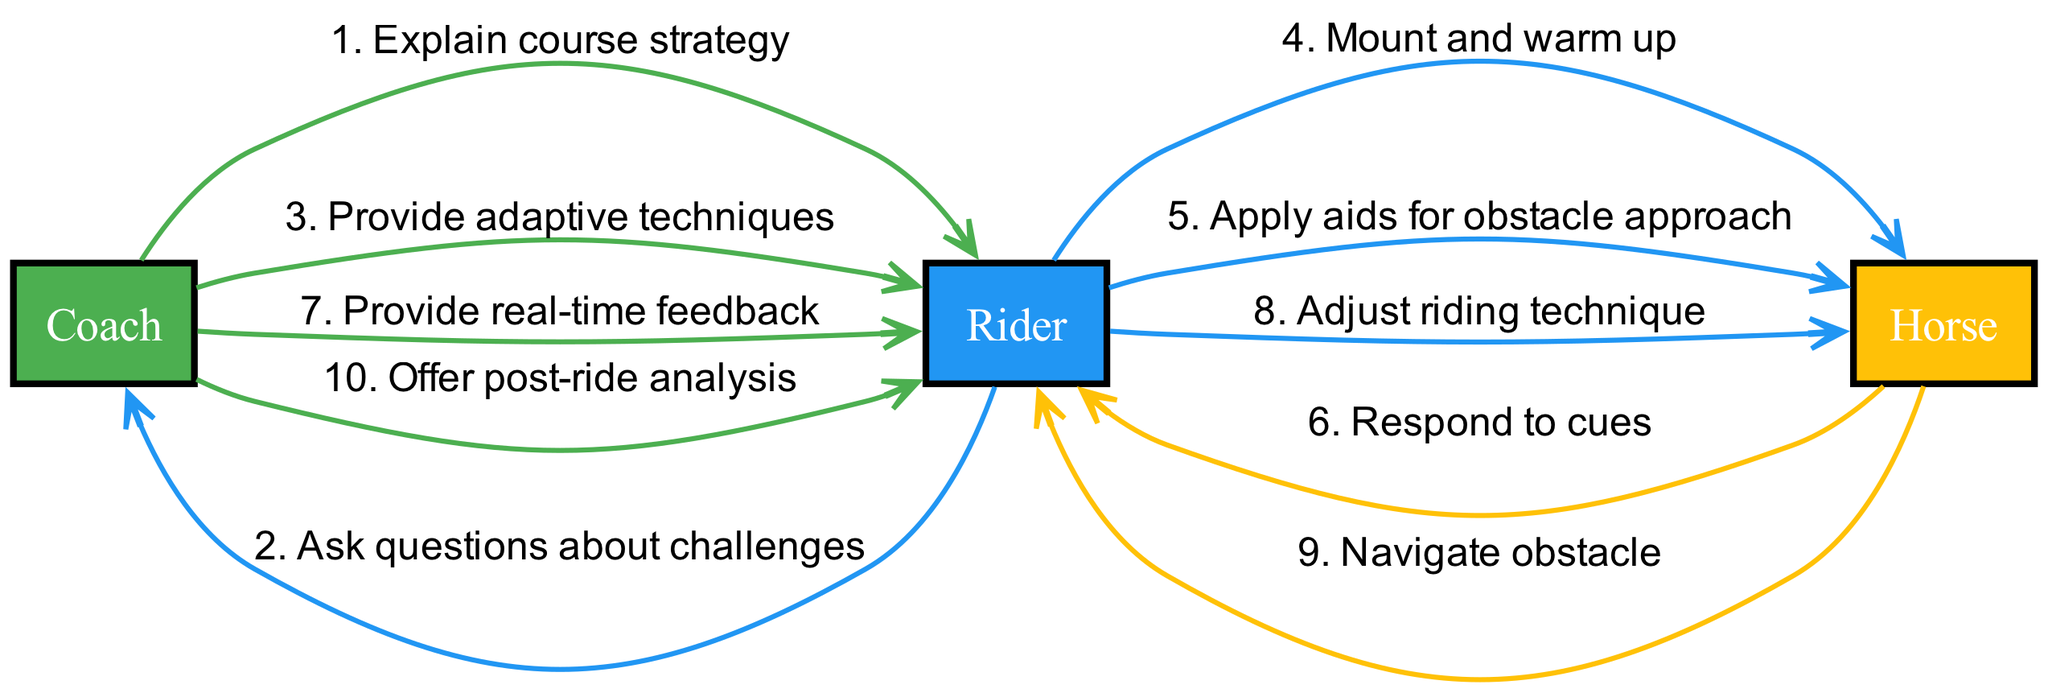What are the three participants in the diagram? The diagram includes three participants: Coach, Rider, and Horse. These are the entities involved in the communication flow during the cross-country course walk and ride.
Answer: Coach, Rider, Horse How many messages are exchanged from the Coach to the Rider? The diagram shows that there are four messages exchanged from the Coach to the Rider, as indicated by the edges leading from Coach to Rider.
Answer: 4 Which message follows the "Ask questions about challenges" message? After the "Ask questions about challenges" message from the Rider to the Coach, the next message is "Provide adaptive techniques" from the Coach to the Rider, indicating a response to the Rider's queries.
Answer: Provide adaptive techniques What is the first interaction involving the Horse? The first interaction involving the Horse occurs when the Rider mounts and warms up, which is the message exchanged from the Rider to the Horse.
Answer: Mount and warm up How many total messages are exchanged in the sequence? The total number of messages exchanged in the sequence is ten, as counted by the number of edges present in the diagram connecting the participants.
Answer: 10 Which participant gives the "Offer post-ride analysis" message? The "Offer post-ride analysis" message is given by the Coach to the Rider at the end of the riding sequence, reflecting an analysis of the performance.
Answer: Coach What is the relationship between the "Navigate obstacle" and "Adjust riding technique" messages? The "Navigate obstacle" message from the Horse follows the "Adjust riding technique" message from the Rider, indicating that the Rider's adjustments influence the Horse's ability to navigate the obstacle.
Answer: Sequential Which participant provides real-time feedback? The Coach provides real-time feedback to the Rider during the riding phase, helping to correct and guide the Rider's performance in real time.
Answer: Coach 